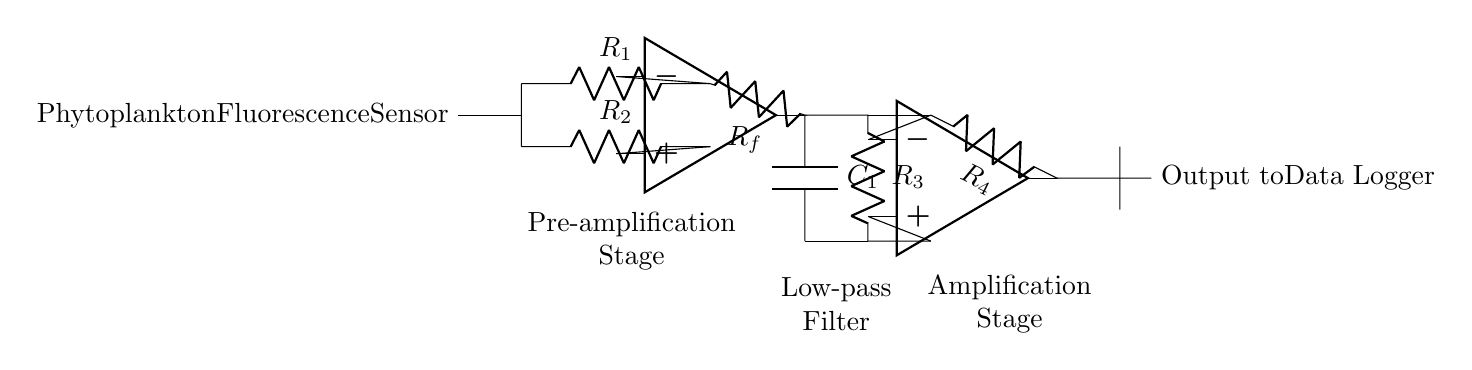What type of sensor is connected at the beginning of the circuit? The circuit diagram shows a phytoplankton fluorescence sensor connected to the circuit, as indicated in the label.
Answer: Phytoplankton Fluorescence Sensor What does the output of the op-amp in the amplification stage connect to? The output of the op-amp in the amplification stage connects to a resistor labeled R4, which leads to the output node.
Answer: R4 What is the purpose of the capacitor labeled C1? The capacitor C1 is part of the low-pass filter, which is designed to smooth out the signal by filtering higher frequency noise components.
Answer: Low-pass filter How many operational amplifiers are used in this circuit? Two operational amplifiers are specified in the circuit: one in the pre-amplification stage and another in the amplification stage.
Answer: Two What is the labeling of the resistor in the pre-amplification stage? The resistors in the pre-amplification stage are labeled R1 and R2, indicating that two resistors are utilized for signal conditioning.
Answer: R1 and R2 What is the primary function of this circuit? The primary function of the circuit is to condition and amplify the signal from the phytoplankton fluorescence sensor, enabling better data acquisition for further analysis.
Answer: Signal conditioning and amplification 